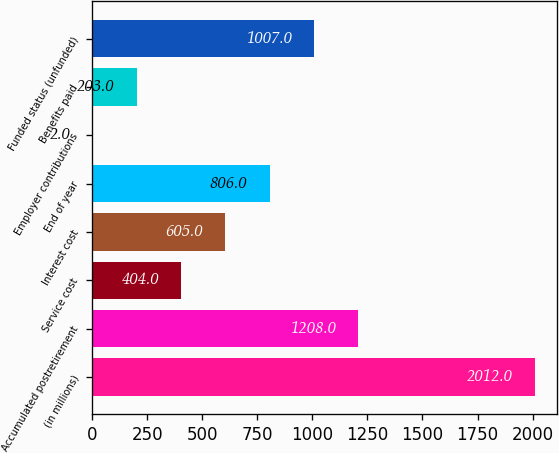<chart> <loc_0><loc_0><loc_500><loc_500><bar_chart><fcel>(in millions)<fcel>Accumulated postretirement<fcel>Service cost<fcel>Interest cost<fcel>End of year<fcel>Employer contributions<fcel>Benefits paid<fcel>Funded status (unfunded)<nl><fcel>2012<fcel>1208<fcel>404<fcel>605<fcel>806<fcel>2<fcel>203<fcel>1007<nl></chart> 